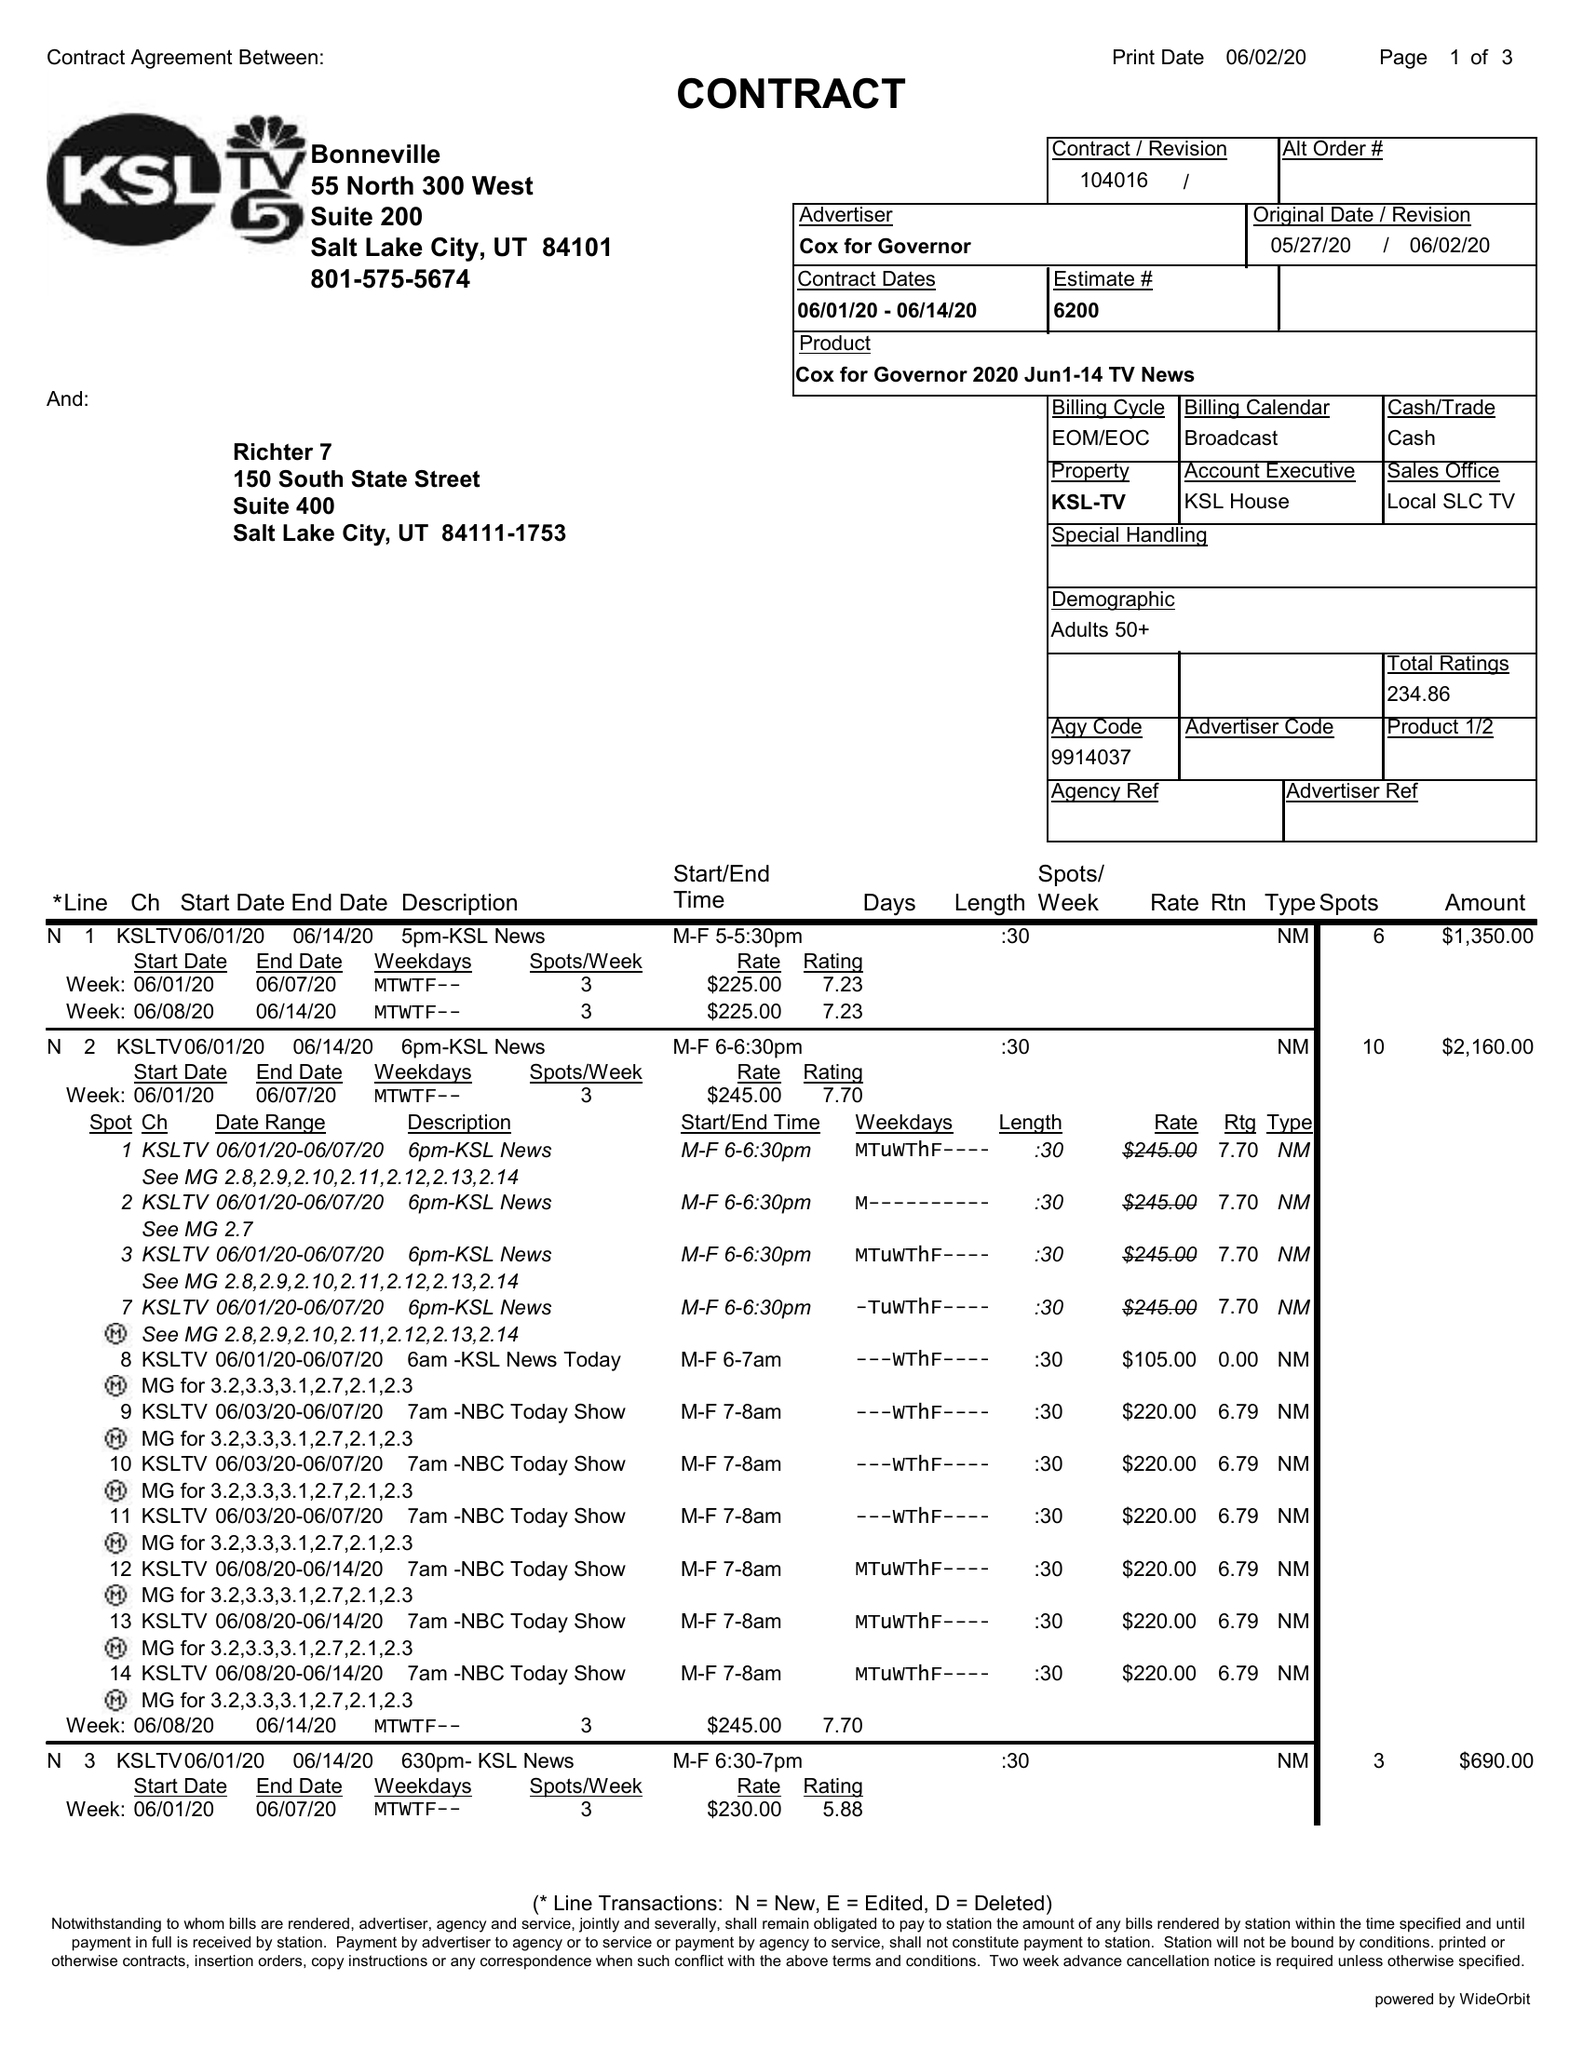What is the value for the flight_from?
Answer the question using a single word or phrase. 06/01/20 